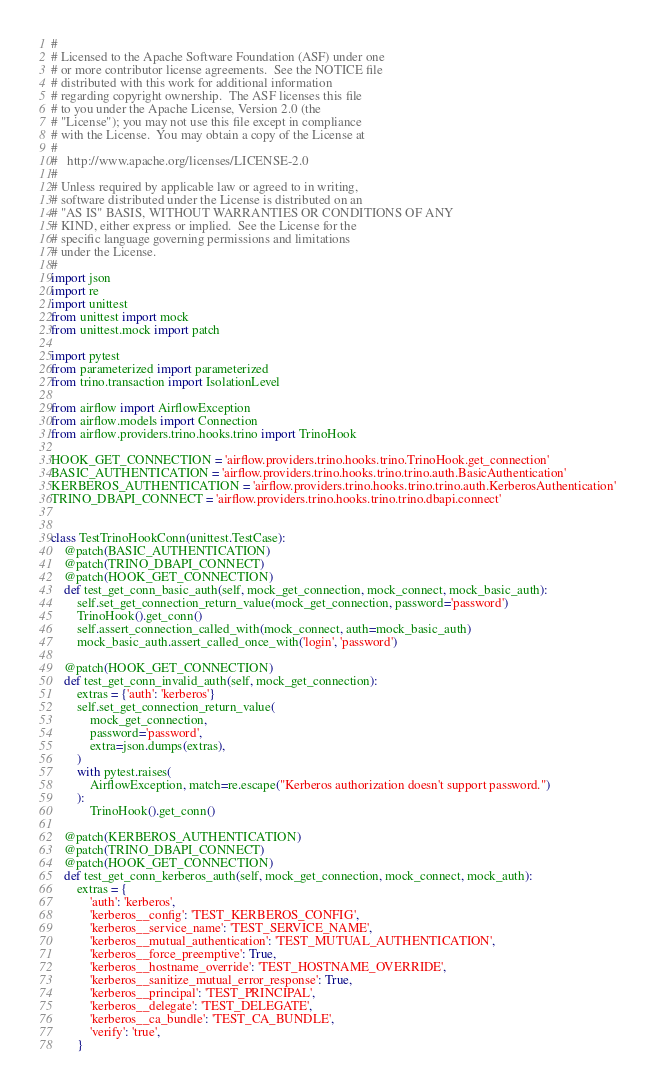<code> <loc_0><loc_0><loc_500><loc_500><_Python_>#
# Licensed to the Apache Software Foundation (ASF) under one
# or more contributor license agreements.  See the NOTICE file
# distributed with this work for additional information
# regarding copyright ownership.  The ASF licenses this file
# to you under the Apache License, Version 2.0 (the
# "License"); you may not use this file except in compliance
# with the License.  You may obtain a copy of the License at
#
#   http://www.apache.org/licenses/LICENSE-2.0
#
# Unless required by applicable law or agreed to in writing,
# software distributed under the License is distributed on an
# "AS IS" BASIS, WITHOUT WARRANTIES OR CONDITIONS OF ANY
# KIND, either express or implied.  See the License for the
# specific language governing permissions and limitations
# under the License.
#
import json
import re
import unittest
from unittest import mock
from unittest.mock import patch

import pytest
from parameterized import parameterized
from trino.transaction import IsolationLevel

from airflow import AirflowException
from airflow.models import Connection
from airflow.providers.trino.hooks.trino import TrinoHook

HOOK_GET_CONNECTION = 'airflow.providers.trino.hooks.trino.TrinoHook.get_connection'
BASIC_AUTHENTICATION = 'airflow.providers.trino.hooks.trino.trino.auth.BasicAuthentication'
KERBEROS_AUTHENTICATION = 'airflow.providers.trino.hooks.trino.trino.auth.KerberosAuthentication'
TRINO_DBAPI_CONNECT = 'airflow.providers.trino.hooks.trino.trino.dbapi.connect'


class TestTrinoHookConn(unittest.TestCase):
    @patch(BASIC_AUTHENTICATION)
    @patch(TRINO_DBAPI_CONNECT)
    @patch(HOOK_GET_CONNECTION)
    def test_get_conn_basic_auth(self, mock_get_connection, mock_connect, mock_basic_auth):
        self.set_get_connection_return_value(mock_get_connection, password='password')
        TrinoHook().get_conn()
        self.assert_connection_called_with(mock_connect, auth=mock_basic_auth)
        mock_basic_auth.assert_called_once_with('login', 'password')

    @patch(HOOK_GET_CONNECTION)
    def test_get_conn_invalid_auth(self, mock_get_connection):
        extras = {'auth': 'kerberos'}
        self.set_get_connection_return_value(
            mock_get_connection,
            password='password',
            extra=json.dumps(extras),
        )
        with pytest.raises(
            AirflowException, match=re.escape("Kerberos authorization doesn't support password.")
        ):
            TrinoHook().get_conn()

    @patch(KERBEROS_AUTHENTICATION)
    @patch(TRINO_DBAPI_CONNECT)
    @patch(HOOK_GET_CONNECTION)
    def test_get_conn_kerberos_auth(self, mock_get_connection, mock_connect, mock_auth):
        extras = {
            'auth': 'kerberos',
            'kerberos__config': 'TEST_KERBEROS_CONFIG',
            'kerberos__service_name': 'TEST_SERVICE_NAME',
            'kerberos__mutual_authentication': 'TEST_MUTUAL_AUTHENTICATION',
            'kerberos__force_preemptive': True,
            'kerberos__hostname_override': 'TEST_HOSTNAME_OVERRIDE',
            'kerberos__sanitize_mutual_error_response': True,
            'kerberos__principal': 'TEST_PRINCIPAL',
            'kerberos__delegate': 'TEST_DELEGATE',
            'kerberos__ca_bundle': 'TEST_CA_BUNDLE',
            'verify': 'true',
        }</code> 